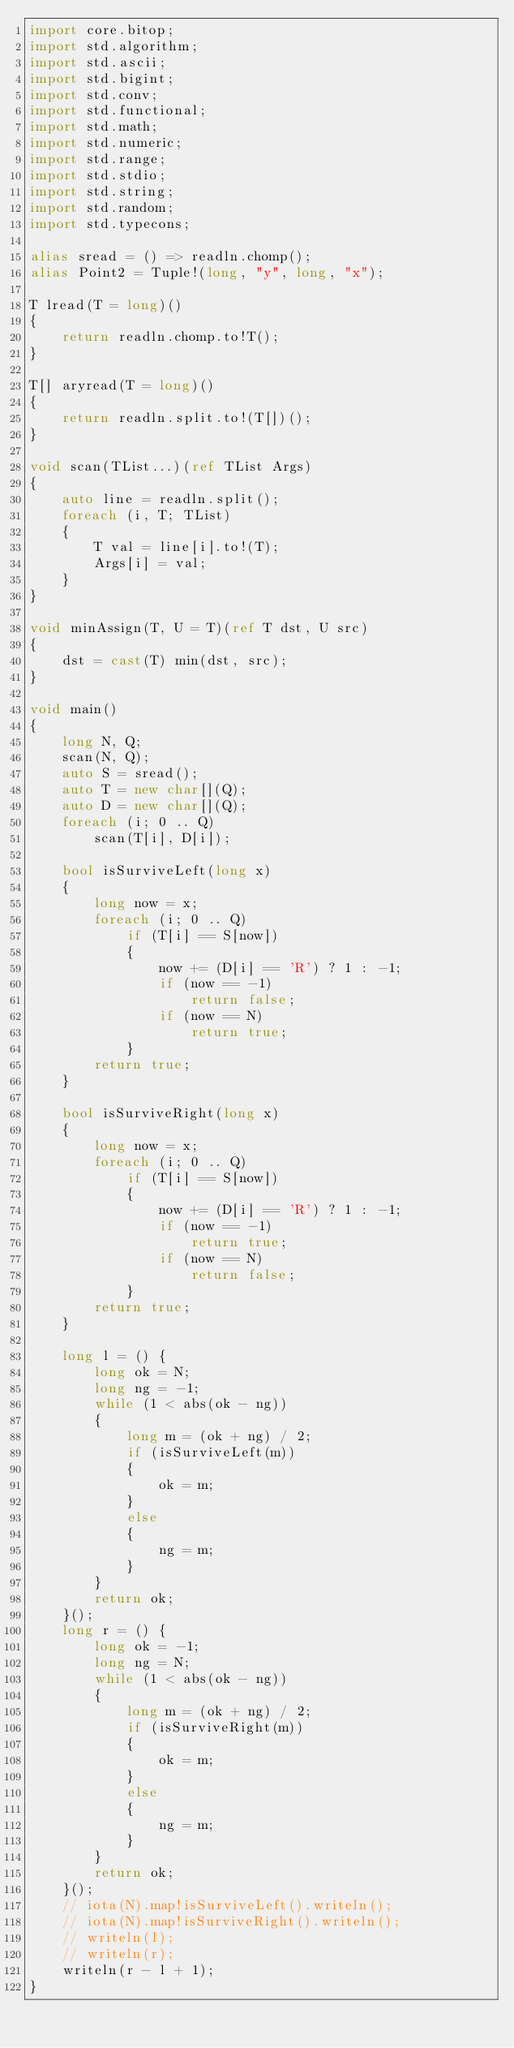<code> <loc_0><loc_0><loc_500><loc_500><_D_>import core.bitop;
import std.algorithm;
import std.ascii;
import std.bigint;
import std.conv;
import std.functional;
import std.math;
import std.numeric;
import std.range;
import std.stdio;
import std.string;
import std.random;
import std.typecons;

alias sread = () => readln.chomp();
alias Point2 = Tuple!(long, "y", long, "x");

T lread(T = long)()
{
    return readln.chomp.to!T();
}

T[] aryread(T = long)()
{
    return readln.split.to!(T[])();
}

void scan(TList...)(ref TList Args)
{
    auto line = readln.split();
    foreach (i, T; TList)
    {
        T val = line[i].to!(T);
        Args[i] = val;
    }
}

void minAssign(T, U = T)(ref T dst, U src)
{
    dst = cast(T) min(dst, src);
}

void main()
{
    long N, Q;
    scan(N, Q);
    auto S = sread();
    auto T = new char[](Q);
    auto D = new char[](Q);
    foreach (i; 0 .. Q)
        scan(T[i], D[i]);

    bool isSurviveLeft(long x)
    {
        long now = x;
        foreach (i; 0 .. Q)
            if (T[i] == S[now])
            {
                now += (D[i] == 'R') ? 1 : -1;
                if (now == -1)
                    return false;
                if (now == N)
                    return true;
            }
        return true;
    }

    bool isSurviveRight(long x)
    {
        long now = x;
        foreach (i; 0 .. Q)
            if (T[i] == S[now])
            {
                now += (D[i] == 'R') ? 1 : -1;
                if (now == -1)
                    return true;
                if (now == N)
                    return false;
            }
        return true;
    }

    long l = () {
        long ok = N;
        long ng = -1;
        while (1 < abs(ok - ng))
        {
            long m = (ok + ng) / 2;
            if (isSurviveLeft(m))
            {
                ok = m;
            }
            else
            {
                ng = m;
            }
        }
        return ok;
    }();
    long r = () {
        long ok = -1;
        long ng = N;
        while (1 < abs(ok - ng))
        {
            long m = (ok + ng) / 2;
            if (isSurviveRight(m))
            {
                ok = m;
            }
            else
            {
                ng = m;
            }
        }
        return ok;
    }();
    // iota(N).map!isSurviveLeft().writeln();
    // iota(N).map!isSurviveRight().writeln();
    // writeln(l);
    // writeln(r);
    writeln(r - l + 1);
}
</code> 